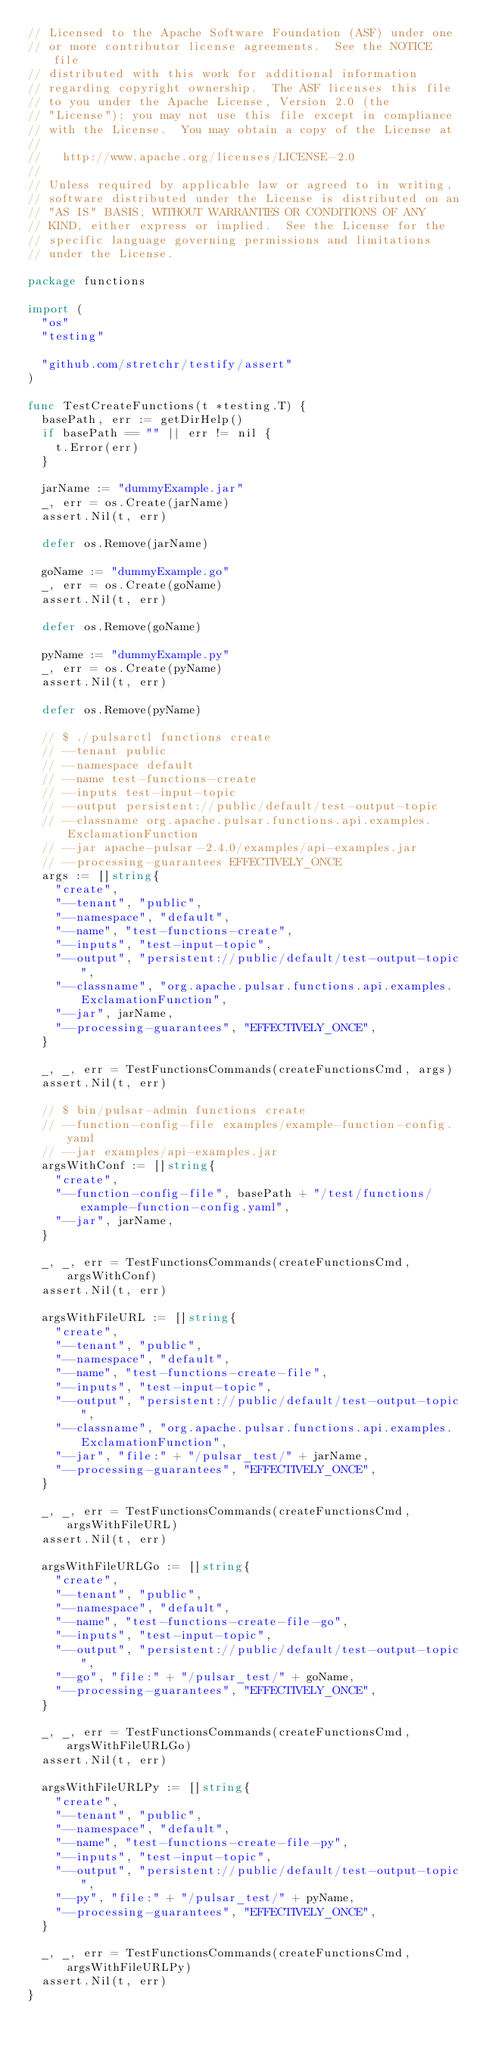<code> <loc_0><loc_0><loc_500><loc_500><_Go_>// Licensed to the Apache Software Foundation (ASF) under one
// or more contributor license agreements.  See the NOTICE file
// distributed with this work for additional information
// regarding copyright ownership.  The ASF licenses this file
// to you under the Apache License, Version 2.0 (the
// "License"); you may not use this file except in compliance
// with the License.  You may obtain a copy of the License at
//
//   http://www.apache.org/licenses/LICENSE-2.0
//
// Unless required by applicable law or agreed to in writing,
// software distributed under the License is distributed on an
// "AS IS" BASIS, WITHOUT WARRANTIES OR CONDITIONS OF ANY
// KIND, either express or implied.  See the License for the
// specific language governing permissions and limitations
// under the License.

package functions

import (
	"os"
	"testing"

	"github.com/stretchr/testify/assert"
)

func TestCreateFunctions(t *testing.T) {
	basePath, err := getDirHelp()
	if basePath == "" || err != nil {
		t.Error(err)
	}

	jarName := "dummyExample.jar"
	_, err = os.Create(jarName)
	assert.Nil(t, err)

	defer os.Remove(jarName)

	goName := "dummyExample.go"
	_, err = os.Create(goName)
	assert.Nil(t, err)

	defer os.Remove(goName)

	pyName := "dummyExample.py"
	_, err = os.Create(pyName)
	assert.Nil(t, err)

	defer os.Remove(pyName)

	// $ ./pulsarctl functions create
	// --tenant public
	// --namespace default
	// --name test-functions-create
	// --inputs test-input-topic
	// --output persistent://public/default/test-output-topic
	// --classname org.apache.pulsar.functions.api.examples.ExclamationFunction
	// --jar apache-pulsar-2.4.0/examples/api-examples.jar
	// --processing-guarantees EFFECTIVELY_ONCE
	args := []string{
		"create",
		"--tenant", "public",
		"--namespace", "default",
		"--name", "test-functions-create",
		"--inputs", "test-input-topic",
		"--output", "persistent://public/default/test-output-topic",
		"--classname", "org.apache.pulsar.functions.api.examples.ExclamationFunction",
		"--jar", jarName,
		"--processing-guarantees", "EFFECTIVELY_ONCE",
	}

	_, _, err = TestFunctionsCommands(createFunctionsCmd, args)
	assert.Nil(t, err)

	// $ bin/pulsar-admin functions create
	// --function-config-file examples/example-function-config.yaml
	// --jar examples/api-examples.jar
	argsWithConf := []string{
		"create",
		"--function-config-file", basePath + "/test/functions/example-function-config.yaml",
		"--jar", jarName,
	}

	_, _, err = TestFunctionsCommands(createFunctionsCmd, argsWithConf)
	assert.Nil(t, err)

	argsWithFileURL := []string{
		"create",
		"--tenant", "public",
		"--namespace", "default",
		"--name", "test-functions-create-file",
		"--inputs", "test-input-topic",
		"--output", "persistent://public/default/test-output-topic",
		"--classname", "org.apache.pulsar.functions.api.examples.ExclamationFunction",
		"--jar", "file:" + "/pulsar_test/" + jarName,
		"--processing-guarantees", "EFFECTIVELY_ONCE",
	}

	_, _, err = TestFunctionsCommands(createFunctionsCmd, argsWithFileURL)
	assert.Nil(t, err)

	argsWithFileURLGo := []string{
		"create",
		"--tenant", "public",
		"--namespace", "default",
		"--name", "test-functions-create-file-go",
		"--inputs", "test-input-topic",
		"--output", "persistent://public/default/test-output-topic",
		"--go", "file:" + "/pulsar_test/" + goName,
		"--processing-guarantees", "EFFECTIVELY_ONCE",
	}

	_, _, err = TestFunctionsCommands(createFunctionsCmd, argsWithFileURLGo)
	assert.Nil(t, err)

	argsWithFileURLPy := []string{
		"create",
		"--tenant", "public",
		"--namespace", "default",
		"--name", "test-functions-create-file-py",
		"--inputs", "test-input-topic",
		"--output", "persistent://public/default/test-output-topic",
		"--py", "file:" + "/pulsar_test/" + pyName,
		"--processing-guarantees", "EFFECTIVELY_ONCE",
	}

	_, _, err = TestFunctionsCommands(createFunctionsCmd, argsWithFileURLPy)
	assert.Nil(t, err)
}
</code> 